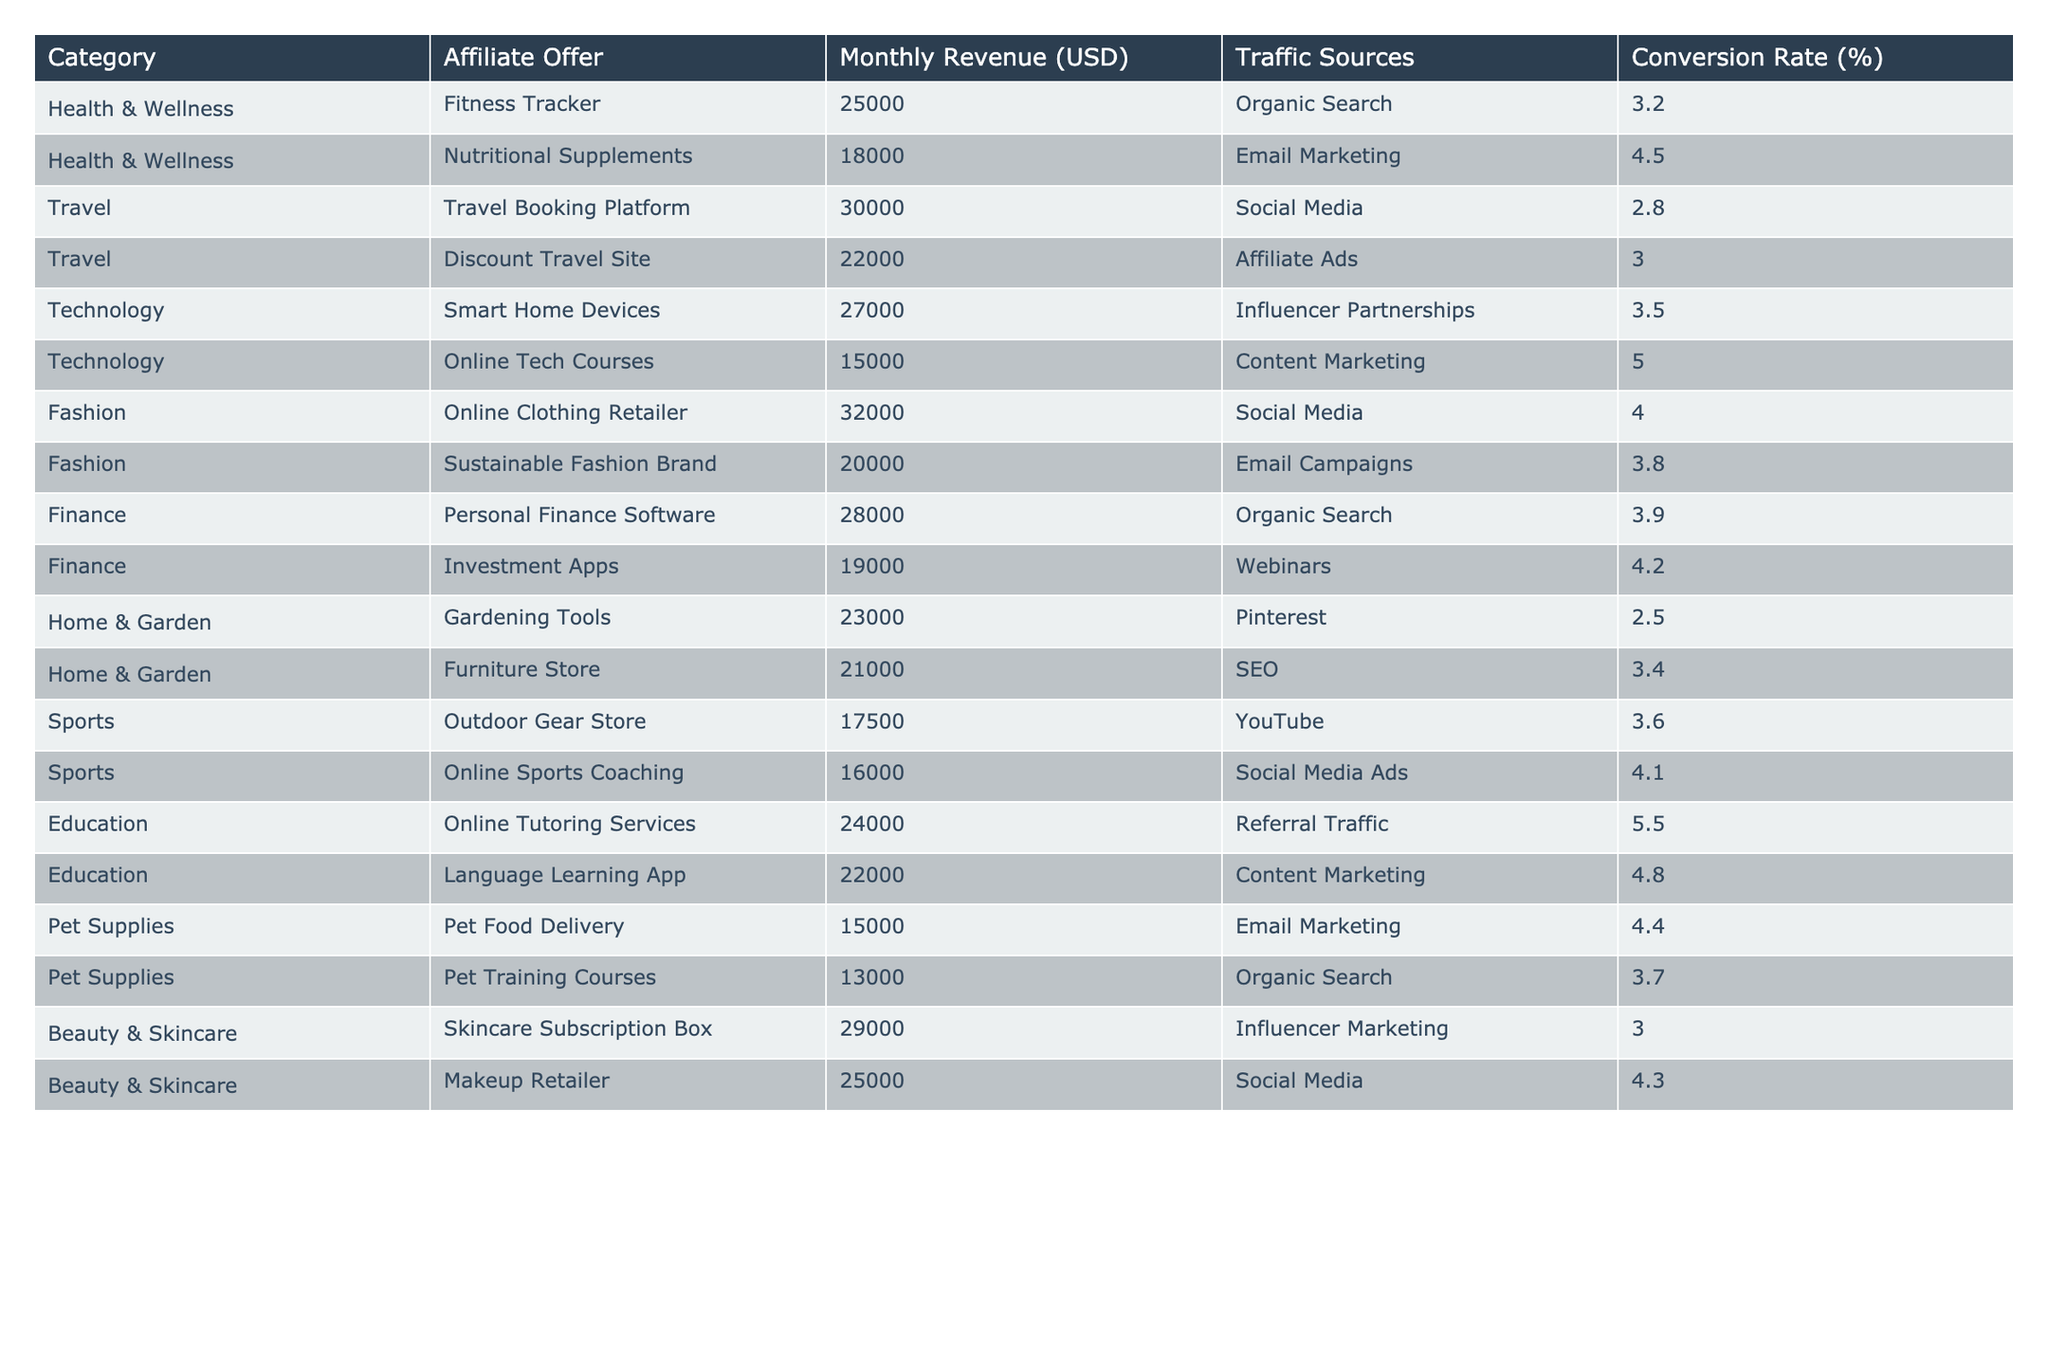What is the Monthly Revenue of the Fitness Tracker offer? The Monthly Revenue for the Fitness Tracker is listed under the Health & Wellness category, which shows a value of 25,000 USD.
Answer: 25,000 Which category has the highest Monthly Revenue? From the table, the category with the highest Monthly Revenue is Fashion, with a total of 32,000 USD from the Online Clothing Retailer offer.
Answer: Fashion What is the average Monthly Revenue for the Technology category? The Monthly Revenues for the Technology category are 27,000 and 15,000. The average is calculated by adding these two values (27,000 + 15,000 = 42,000) and dividing by 2, resulting in 21,000 USD.
Answer: 21,000 Is the Conversion Rate for the Nutritional Supplements offer greater than 4%? The Conversion Rate listed for the Nutritional Supplements is 4.5%, which is greater than 4%.
Answer: Yes What is the total Monthly Revenue for the Travel category? The Monthly Revenues for the Travel category are 30,000 and 22,000. Summing these values (30,000 + 22,000 = 52,000) gives the total Monthly Revenue for the Travel category as 52,000 USD.
Answer: 52,000 How many offers have a Conversion Rate above 4%? The Conversion Rates above 4% are for Nutritional Supplements (4.5%), Online Tech Courses (5.0%), Sustainable Fashion Brand (3.8%), Investment Apps (4.2%), Online Tutoring Services (5.5%), and Makeup Retailer (4.3%). Counting these, there are 6 offers with a Conversion Rate above 4%.
Answer: 6 What is the difference in Monthly Revenue between the highest and lowest offer in the Health & Wellness category? The Monthly Revenues in the Health & Wellness category are 25,000 for Fitness Tracker and 18,000 for Nutritional Supplements. The difference is calculated as 25,000 - 18,000 = 7,000.
Answer: 7,000 Which affiliate offer has the lowest Monthly Revenue? The Pet Training Courses offer has the lowest Monthly Revenue at 13,000 USD, when compared with all other offers in the table.
Answer: Pet Training Courses Which Traffic Source has the highest average Monthly Revenue based on the table data? The Traffic Sources can be grouped, and their corresponding Monthly Revenues are added. The averages are calculated as follows: Organic Search (25,000 + 18,000 + 13,000 = 56,000 / 3 = 18,666.67), Email Marketing (18,000 + 15,000 = 33,000 / 2 = 16,500), Social Media (30,000 + 32,000 + 16,000 = 78,000 / 3 = 26,000), Influencer Partnerships (27,000 + 29,000 = 56,000 / 2 = 28,000), and others like that. Influencer Partnerships has the highest average at 28,000 USD.
Answer: Influencer Partnerships Are there any offers in the Education category with a Monthly Revenue exceeding 25,000 USD? The Monthly Revenues in the Education category are 24,000 and 22,000. Both are below 25,000, meaning there are no offers over that amount.
Answer: No 